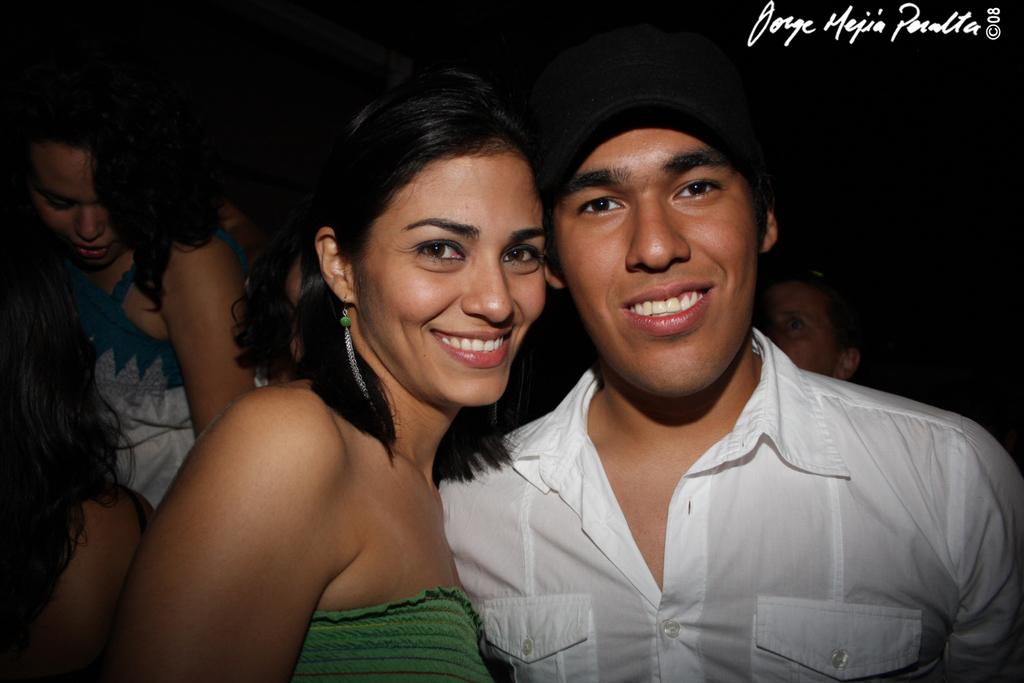How many people are present in the image? There are two people in the image: a man and a woman. Are there any other people in the image besides the man and woman? Yes, there is another woman on the left side of the image. What color can be seen in the background of the image? In the background, there is a black color. Can you describe anything specific about the background? The head of a person is visible in the background. How much profit did the snail make in the image? There is no snail present in the image, so it is not possible to determine any profit made by a snail. 